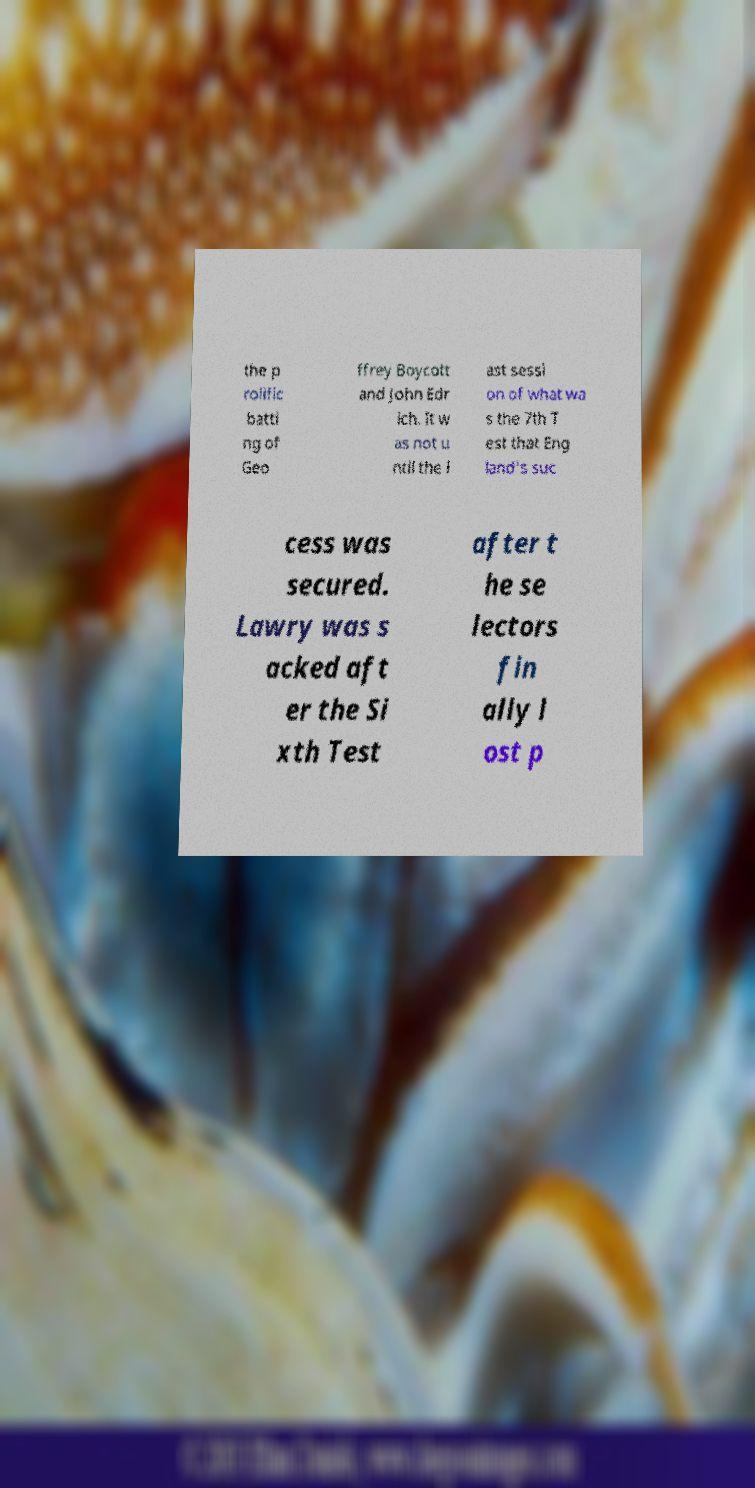I need the written content from this picture converted into text. Can you do that? the p rolific batti ng of Geo ffrey Boycott and John Edr ich. It w as not u ntil the l ast sessi on of what wa s the 7th T est that Eng land's suc cess was secured. Lawry was s acked aft er the Si xth Test after t he se lectors fin ally l ost p 